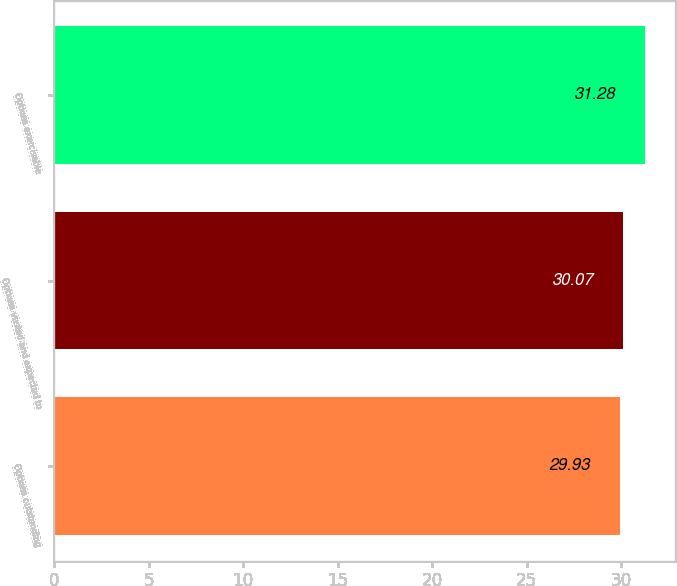Convert chart to OTSL. <chart><loc_0><loc_0><loc_500><loc_500><bar_chart><fcel>Options outstanding<fcel>Options vested and expected to<fcel>Options exercisable<nl><fcel>29.93<fcel>30.07<fcel>31.28<nl></chart> 